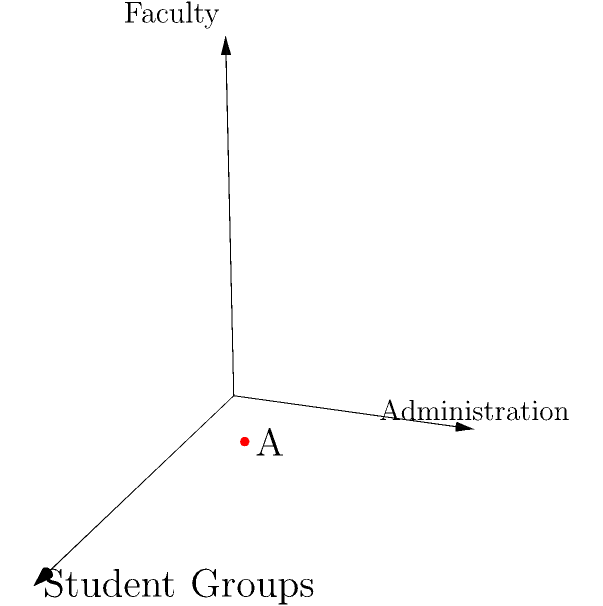In a 3D coordinate system representing the balance of power between student groups (x-axis), administration (y-axis), and faculty (z-axis), point A is located at (3, 2, 1). What does this point suggest about the current power dynamics in the university, and how might you, as a law professor, facilitate a dialogue to achieve a more balanced distribution of influence? To analyze the power dynamics represented by point A (3, 2, 1), let's break it down step-by-step:

1. Interpret the coordinates:
   x = 3 (Student Groups)
   y = 2 (Administration)
   z = 1 (Faculty)

2. Compare the values:
   Student Groups (3) > Administration (2) > Faculty (1)

3. Relative influence:
   - Student Groups have the most influence
   - Administration has moderate influence
   - Faculty has the least influence

4. Implications:
   - There might be strong student activism or well-organized student bodies
   - Administration has less control than usual
   - Faculty's voice seems to be underrepresented

5. Facilitating dialogue:
   a) Recognize the strengths of student engagement
   b) Acknowledge the administration's role in decision-making
   c) Emphasize the importance of faculty expertise and experience

6. Steps to balance power:
   a) Organize roundtable discussions with representatives from all groups
   b) Propose joint committees with equal representation
   c) Develop a system of checks and balances for major decisions
   d) Encourage mentorship programs between faculty and students
   e) Promote transparency in administrative processes

7. Role as a law professor:
   a) Use legal frameworks to explain the importance of balanced governance
   b) Teach negotiation and mediation skills to all parties
   c) Highlight historical examples of successful power-sharing in institutions
   d) Facilitate mock scenarios to practice collaborative decision-making

8. Goal: Move towards a more balanced point, such as (2, 2, 2), where all parties have equal influence.
Answer: Point A suggests an imbalance favoring student groups. Facilitate dialogue through roundtable discussions, joint committees, and emphasizing collaborative decision-making to achieve a more balanced (2, 2, 2) distribution. 